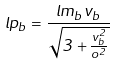<formula> <loc_0><loc_0><loc_500><loc_500>l p _ { b } = \frac { l m _ { b } v _ { b } } { \sqrt { 3 + \frac { v _ { b } ^ { 2 } } { o ^ { 2 } } } }</formula> 